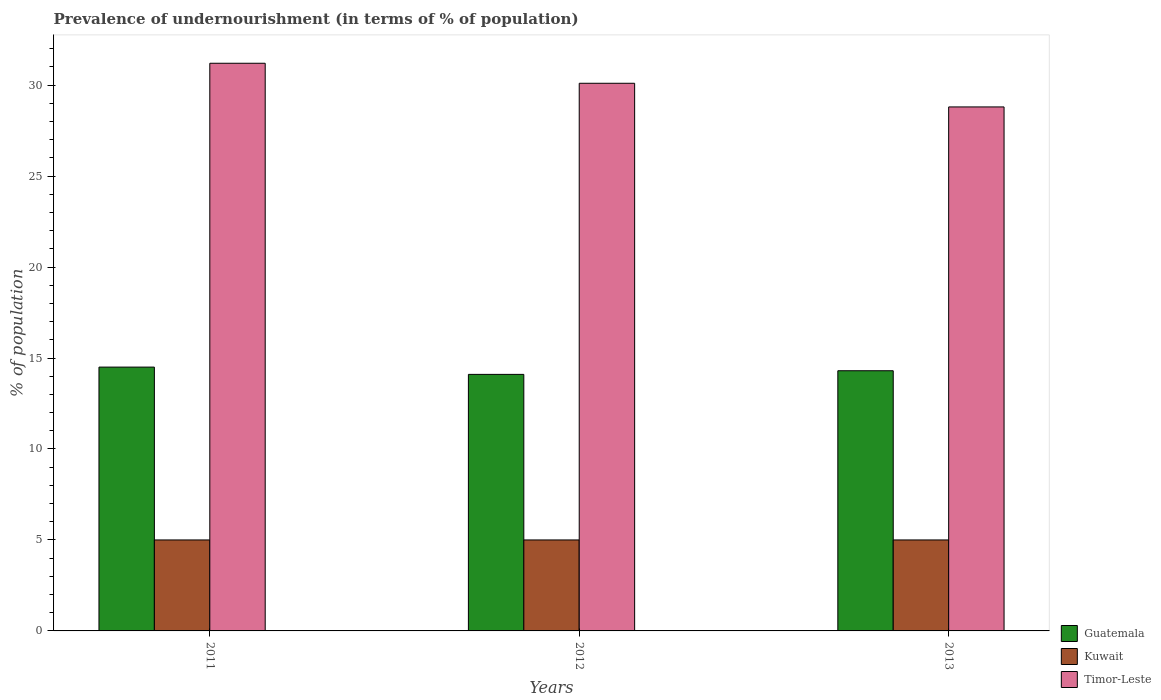How many groups of bars are there?
Make the answer very short. 3. Are the number of bars on each tick of the X-axis equal?
Your answer should be very brief. Yes. How many bars are there on the 3rd tick from the right?
Keep it short and to the point. 3. What is the label of the 2nd group of bars from the left?
Ensure brevity in your answer.  2012. What is the percentage of undernourished population in Kuwait in 2013?
Offer a terse response. 5. Across all years, what is the maximum percentage of undernourished population in Timor-Leste?
Ensure brevity in your answer.  31.2. What is the total percentage of undernourished population in Kuwait in the graph?
Provide a succinct answer. 15. What is the difference between the percentage of undernourished population in Kuwait in 2011 and that in 2013?
Your response must be concise. 0. What is the difference between the percentage of undernourished population in Kuwait in 2012 and the percentage of undernourished population in Guatemala in 2013?
Offer a very short reply. -9.3. What is the average percentage of undernourished population in Guatemala per year?
Your answer should be very brief. 14.3. Is the difference between the percentage of undernourished population in Kuwait in 2011 and 2012 greater than the difference between the percentage of undernourished population in Guatemala in 2011 and 2012?
Provide a short and direct response. No. What is the difference between the highest and the second highest percentage of undernourished population in Timor-Leste?
Provide a succinct answer. 1.1. What is the difference between the highest and the lowest percentage of undernourished population in Guatemala?
Offer a very short reply. 0.4. Is the sum of the percentage of undernourished population in Timor-Leste in 2012 and 2013 greater than the maximum percentage of undernourished population in Kuwait across all years?
Keep it short and to the point. Yes. What does the 2nd bar from the left in 2012 represents?
Provide a short and direct response. Kuwait. What does the 3rd bar from the right in 2012 represents?
Keep it short and to the point. Guatemala. Does the graph contain any zero values?
Provide a succinct answer. No. How are the legend labels stacked?
Offer a terse response. Vertical. What is the title of the graph?
Offer a terse response. Prevalence of undernourishment (in terms of % of population). What is the label or title of the Y-axis?
Provide a succinct answer. % of population. What is the % of population in Guatemala in 2011?
Your answer should be very brief. 14.5. What is the % of population of Timor-Leste in 2011?
Keep it short and to the point. 31.2. What is the % of population of Guatemala in 2012?
Offer a very short reply. 14.1. What is the % of population in Kuwait in 2012?
Your answer should be very brief. 5. What is the % of population of Timor-Leste in 2012?
Make the answer very short. 30.1. What is the % of population in Guatemala in 2013?
Your answer should be very brief. 14.3. What is the % of population in Timor-Leste in 2013?
Your answer should be very brief. 28.8. Across all years, what is the maximum % of population of Timor-Leste?
Your response must be concise. 31.2. Across all years, what is the minimum % of population of Kuwait?
Your answer should be very brief. 5. Across all years, what is the minimum % of population in Timor-Leste?
Offer a very short reply. 28.8. What is the total % of population in Guatemala in the graph?
Keep it short and to the point. 42.9. What is the total % of population in Timor-Leste in the graph?
Offer a terse response. 90.1. What is the difference between the % of population in Kuwait in 2011 and that in 2012?
Your answer should be compact. 0. What is the difference between the % of population of Timor-Leste in 2011 and that in 2012?
Ensure brevity in your answer.  1.1. What is the difference between the % of population in Guatemala in 2011 and that in 2013?
Ensure brevity in your answer.  0.2. What is the difference between the % of population in Guatemala in 2012 and that in 2013?
Offer a terse response. -0.2. What is the difference between the % of population of Guatemala in 2011 and the % of population of Kuwait in 2012?
Provide a short and direct response. 9.5. What is the difference between the % of population in Guatemala in 2011 and the % of population in Timor-Leste in 2012?
Provide a succinct answer. -15.6. What is the difference between the % of population of Kuwait in 2011 and the % of population of Timor-Leste in 2012?
Offer a very short reply. -25.1. What is the difference between the % of population in Guatemala in 2011 and the % of population in Timor-Leste in 2013?
Your response must be concise. -14.3. What is the difference between the % of population in Kuwait in 2011 and the % of population in Timor-Leste in 2013?
Your response must be concise. -23.8. What is the difference between the % of population of Guatemala in 2012 and the % of population of Kuwait in 2013?
Provide a succinct answer. 9.1. What is the difference between the % of population in Guatemala in 2012 and the % of population in Timor-Leste in 2013?
Keep it short and to the point. -14.7. What is the difference between the % of population of Kuwait in 2012 and the % of population of Timor-Leste in 2013?
Give a very brief answer. -23.8. What is the average % of population of Guatemala per year?
Provide a succinct answer. 14.3. What is the average % of population in Timor-Leste per year?
Your answer should be very brief. 30.03. In the year 2011, what is the difference between the % of population of Guatemala and % of population of Kuwait?
Give a very brief answer. 9.5. In the year 2011, what is the difference between the % of population of Guatemala and % of population of Timor-Leste?
Keep it short and to the point. -16.7. In the year 2011, what is the difference between the % of population of Kuwait and % of population of Timor-Leste?
Your answer should be very brief. -26.2. In the year 2012, what is the difference between the % of population in Guatemala and % of population in Kuwait?
Provide a succinct answer. 9.1. In the year 2012, what is the difference between the % of population of Kuwait and % of population of Timor-Leste?
Give a very brief answer. -25.1. In the year 2013, what is the difference between the % of population in Guatemala and % of population in Timor-Leste?
Your response must be concise. -14.5. In the year 2013, what is the difference between the % of population of Kuwait and % of population of Timor-Leste?
Provide a short and direct response. -23.8. What is the ratio of the % of population of Guatemala in 2011 to that in 2012?
Your answer should be compact. 1.03. What is the ratio of the % of population in Timor-Leste in 2011 to that in 2012?
Give a very brief answer. 1.04. What is the ratio of the % of population of Kuwait in 2011 to that in 2013?
Offer a very short reply. 1. What is the ratio of the % of population in Timor-Leste in 2012 to that in 2013?
Your answer should be very brief. 1.05. What is the difference between the highest and the second highest % of population in Guatemala?
Provide a succinct answer. 0.2. What is the difference between the highest and the second highest % of population of Timor-Leste?
Provide a succinct answer. 1.1. What is the difference between the highest and the lowest % of population in Guatemala?
Provide a succinct answer. 0.4. 